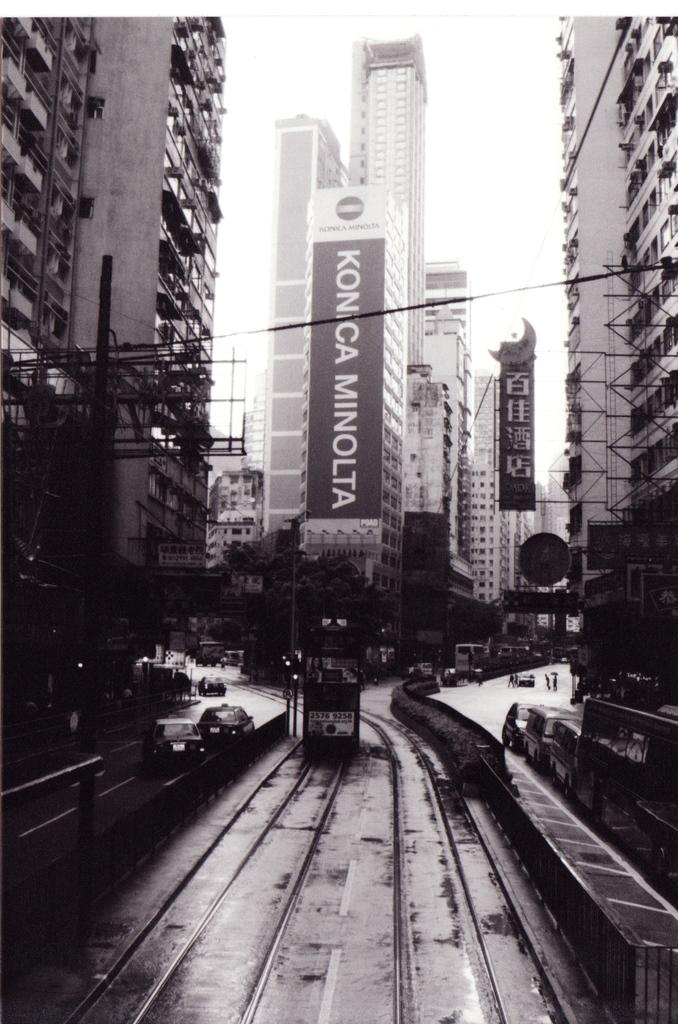<image>
Summarize the visual content of the image. Big black and white Konica Minolta sign on a building. 